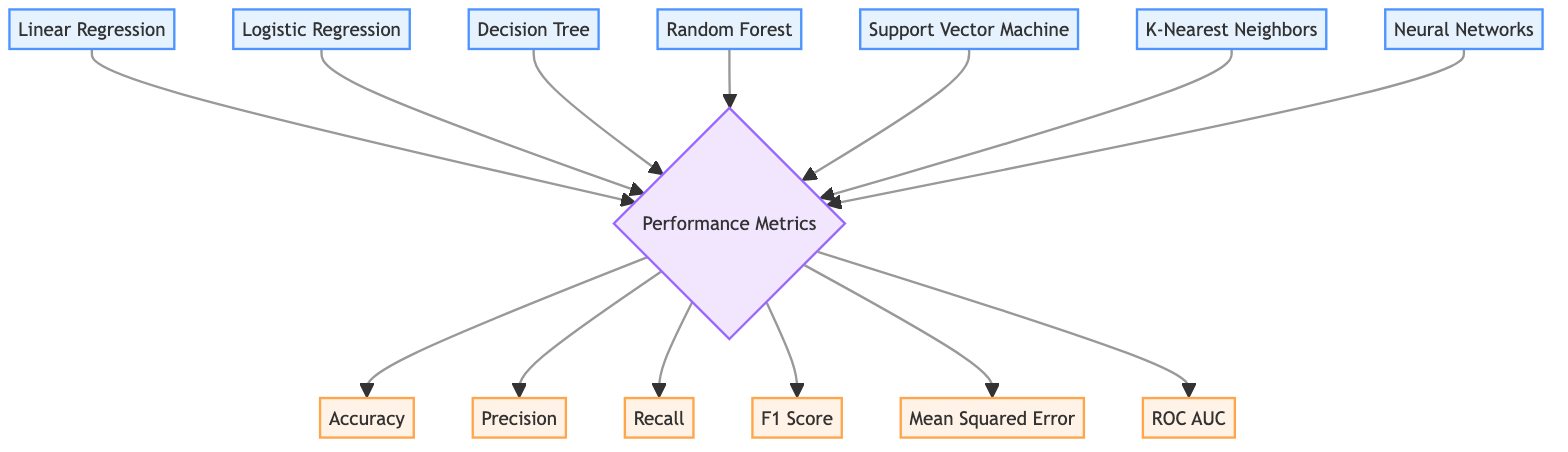What algorithms are represented in the diagram? The diagram shows four algorithms: Linear Regression, Logistic Regression, Decision Tree, Random Forest, Support Vector Machine, K-Nearest Neighbors, and Neural Networks.
Answer: Linear Regression, Logistic Regression, Decision Tree, Random Forest, Support Vector Machine, K-Nearest Neighbors, Neural Networks How many performance metrics are included in the diagram? The diagram includes six performance metrics: Accuracy, Precision, Recall, F1 Score, Mean Squared Error, and ROC AUC. Counting these metrics gives a total of six.
Answer: Six What type of relationship exists between the algorithms and performance metrics? The relationship between algorithms and performance metrics is depicted as a direct connection; each algorithm points to the Performance Metrics node, indicating that they can be evaluated based on these metrics.
Answer: Direct connection Which performance metric is represented at the top of the list? The performance metrics are arranged with Accuracy positioned at the top. The order places Accuracy first before others, making it the most prominent metric.
Answer: Accuracy How many algorithms point to the Performance Metrics node? Seven algorithms (Linear Regression, Logistic Regression, Decision Tree, Random Forest, Support Vector Machine, K-Nearest Neighbors, and Neural Networks) point to the Performance Metrics node, indicating that each can be evaluated using these metrics.
Answer: Seven What is the primary focus of the diagram? The primary focus of the diagram is to compare different machine learning algorithms and their performance metrics, emphasizing the relationships between the algorithms and metrics used for evaluation.
Answer: Comparison of algorithms and performance metrics Which performance metric does not have an actual numerical value shown in the diagram? The diagram presents all performance metrics as nodes connected to the Performance Metrics node, without numerical values; they indicate types of evaluation rather than quantified performance.
Answer: None 